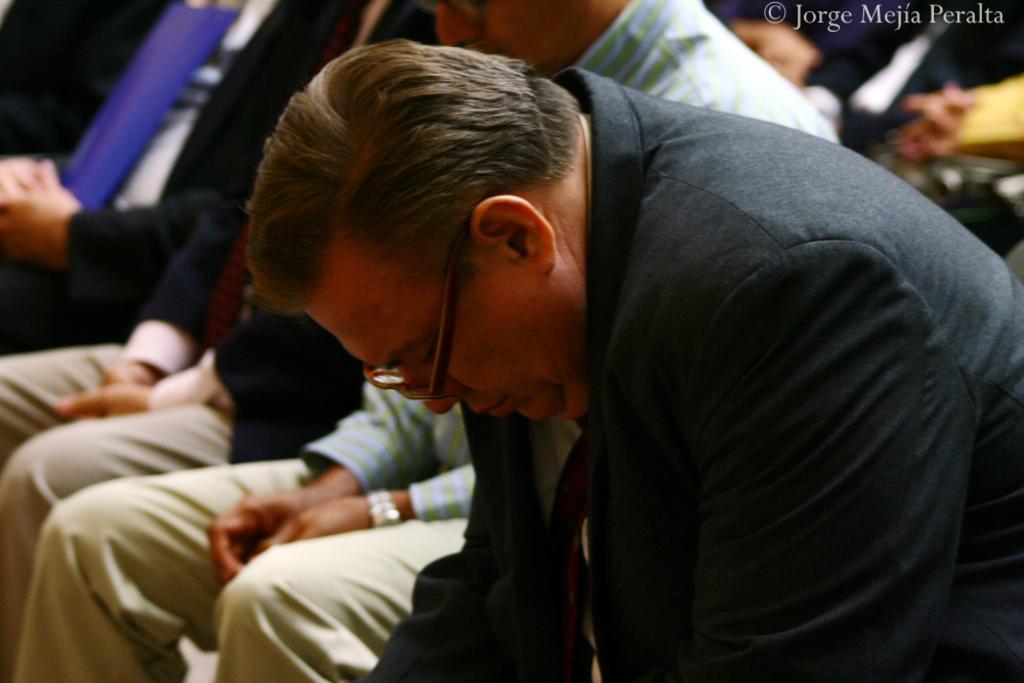Can you describe this image briefly? In this picture we observe several people sitting on the chairs and giving condolences. 